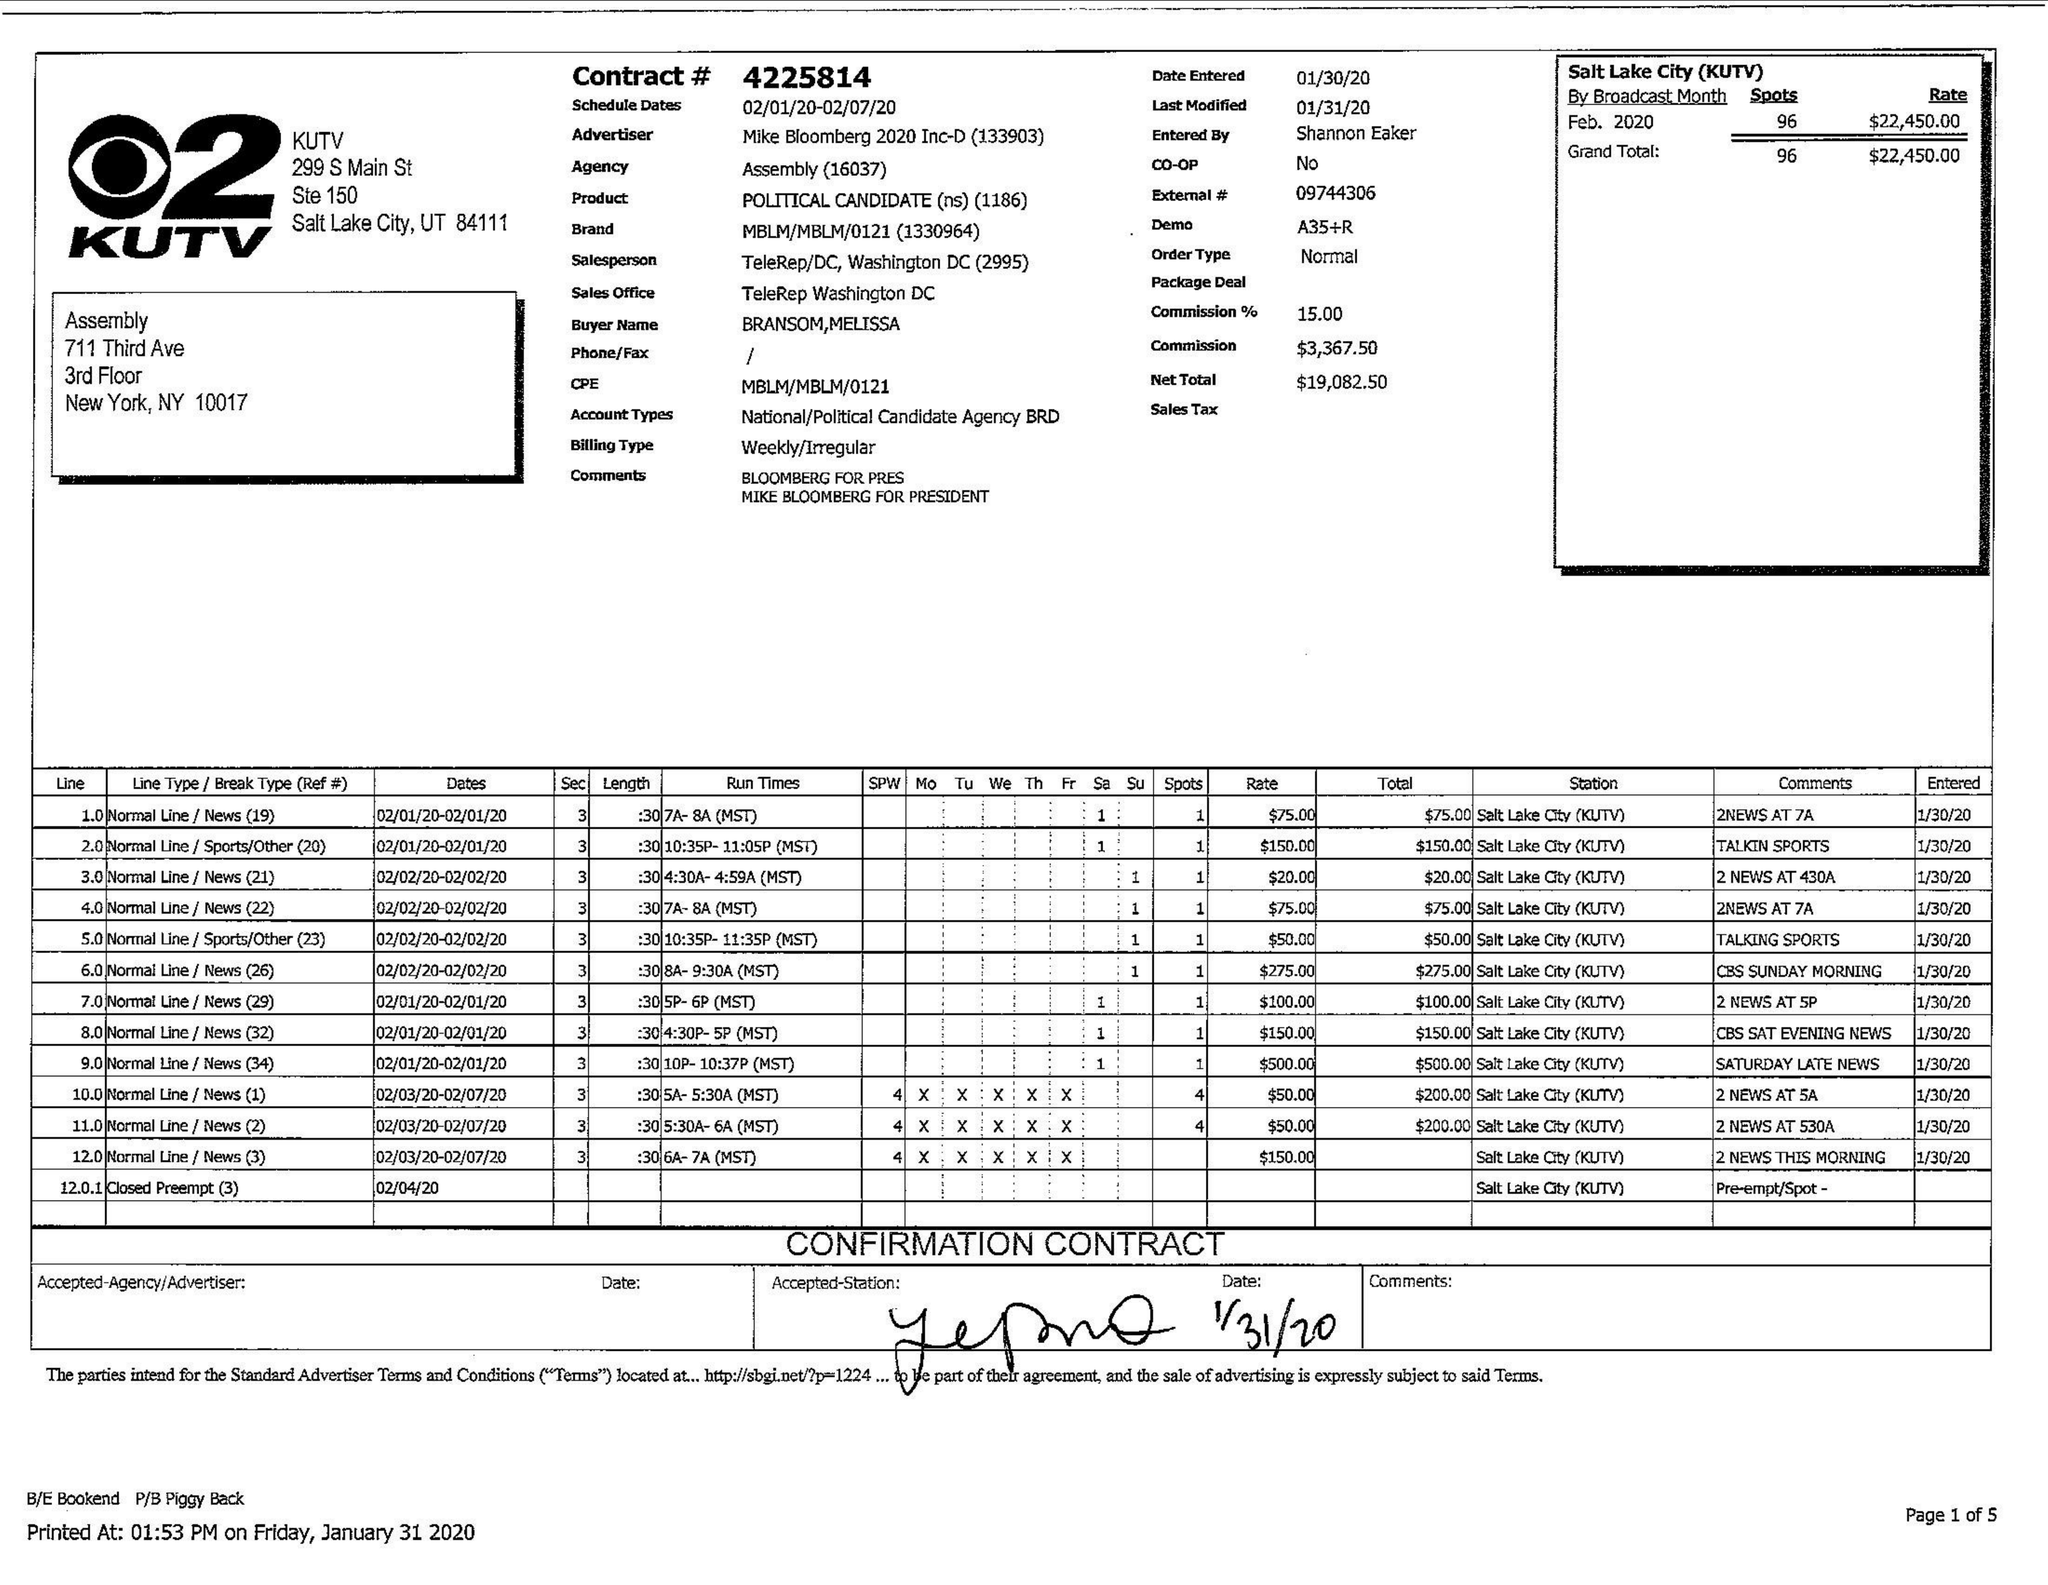What is the value for the flight_to?
Answer the question using a single word or phrase. 02/07/20 